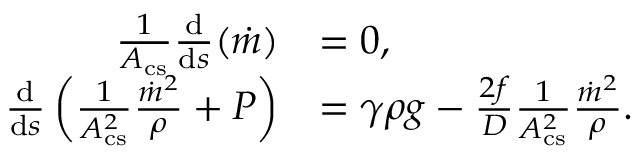Convert formula to latex. <formula><loc_0><loc_0><loc_500><loc_500>\begin{array} { r l } { \frac { 1 } { A _ { c s } } \frac { d } { d s } ( \dot { m } ) } & { = 0 , } \\ { \frac { d } { d s } \left ( \frac { 1 } { A _ { c s } ^ { 2 } } \frac { \dot { m } ^ { 2 } } { \rho } + P \right ) } & { = \gamma \rho g - \frac { 2 f } { D } \frac { 1 } { A _ { c s } ^ { 2 } } \frac { \dot { m } ^ { 2 } } { \rho } . } \end{array}</formula> 